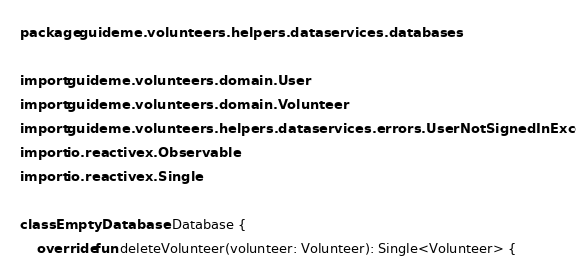Convert code to text. <code><loc_0><loc_0><loc_500><loc_500><_Kotlin_>package guideme.volunteers.helpers.dataservices.databases

import guideme.volunteers.domain.User
import guideme.volunteers.domain.Volunteer
import guideme.volunteers.helpers.dataservices.errors.UserNotSignedInException
import io.reactivex.Observable
import io.reactivex.Single

class EmptyDatabase : Database {
    override fun deleteVolunteer(volunteer: Volunteer): Single<Volunteer> {</code> 